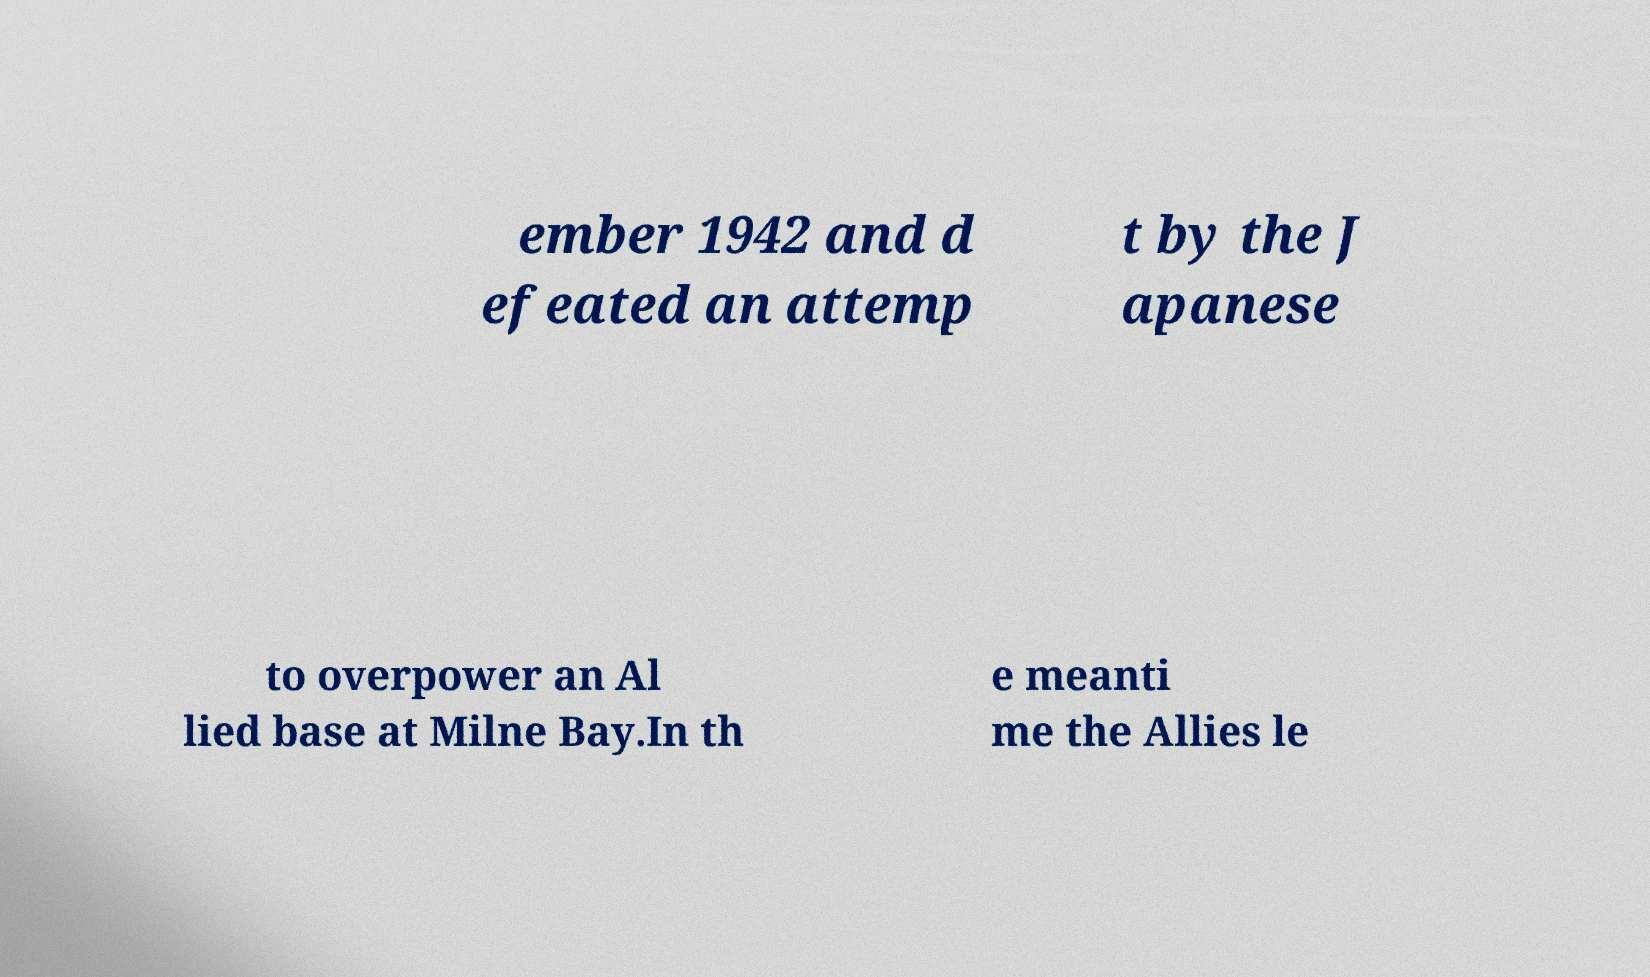Can you accurately transcribe the text from the provided image for me? ember 1942 and d efeated an attemp t by the J apanese to overpower an Al lied base at Milne Bay.In th e meanti me the Allies le 